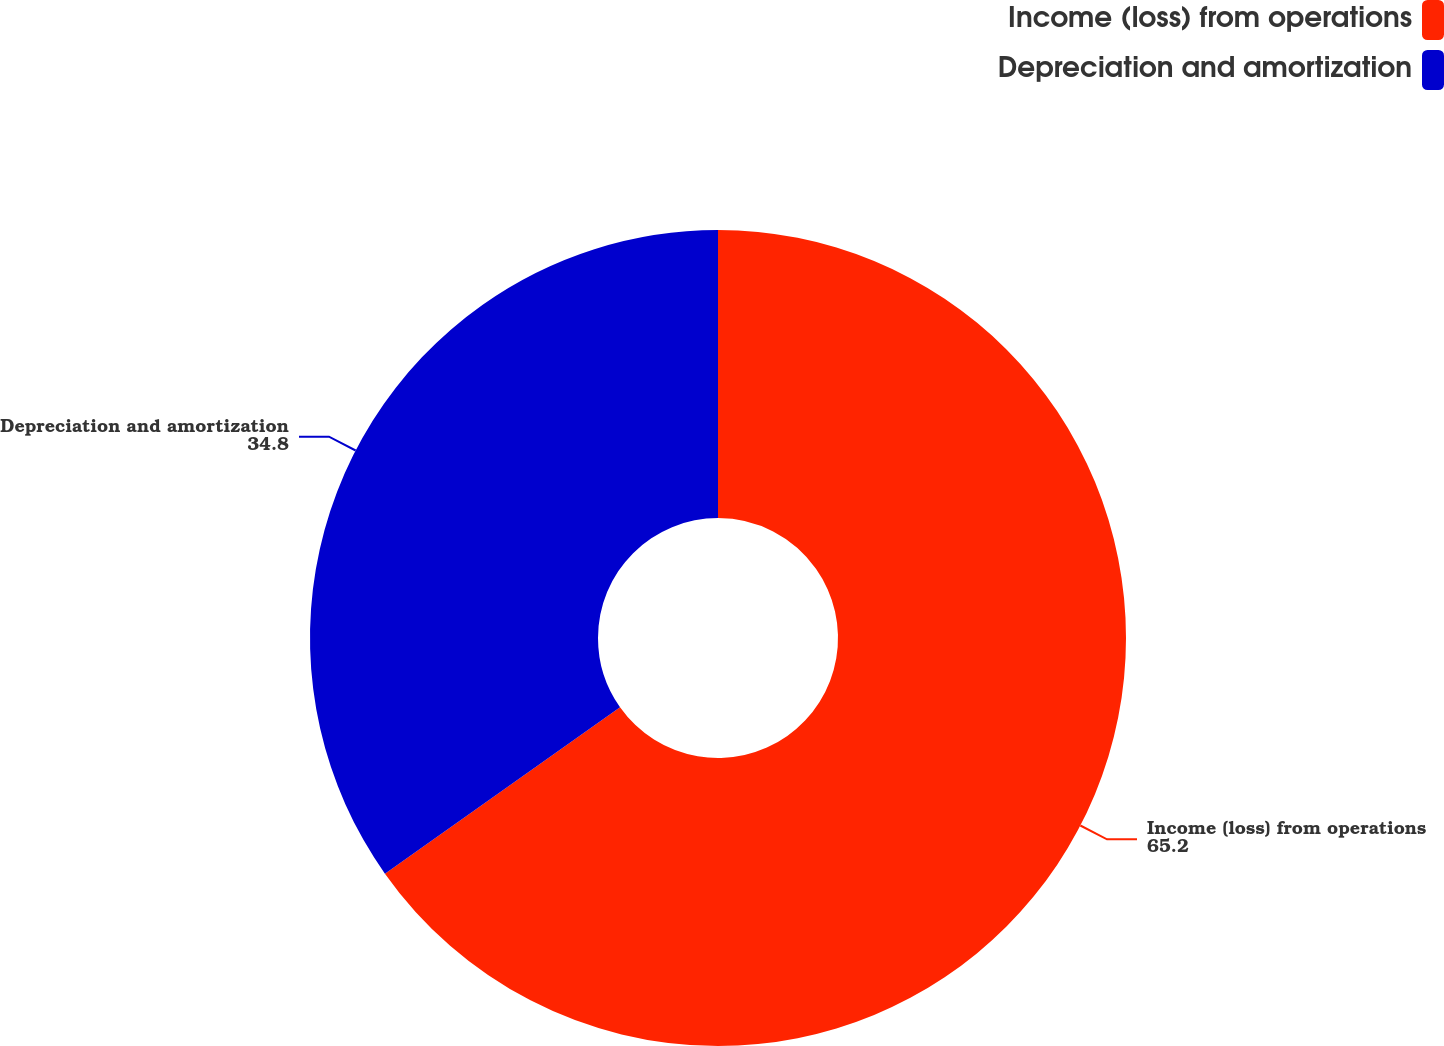Convert chart to OTSL. <chart><loc_0><loc_0><loc_500><loc_500><pie_chart><fcel>Income (loss) from operations<fcel>Depreciation and amortization<nl><fcel>65.2%<fcel>34.8%<nl></chart> 